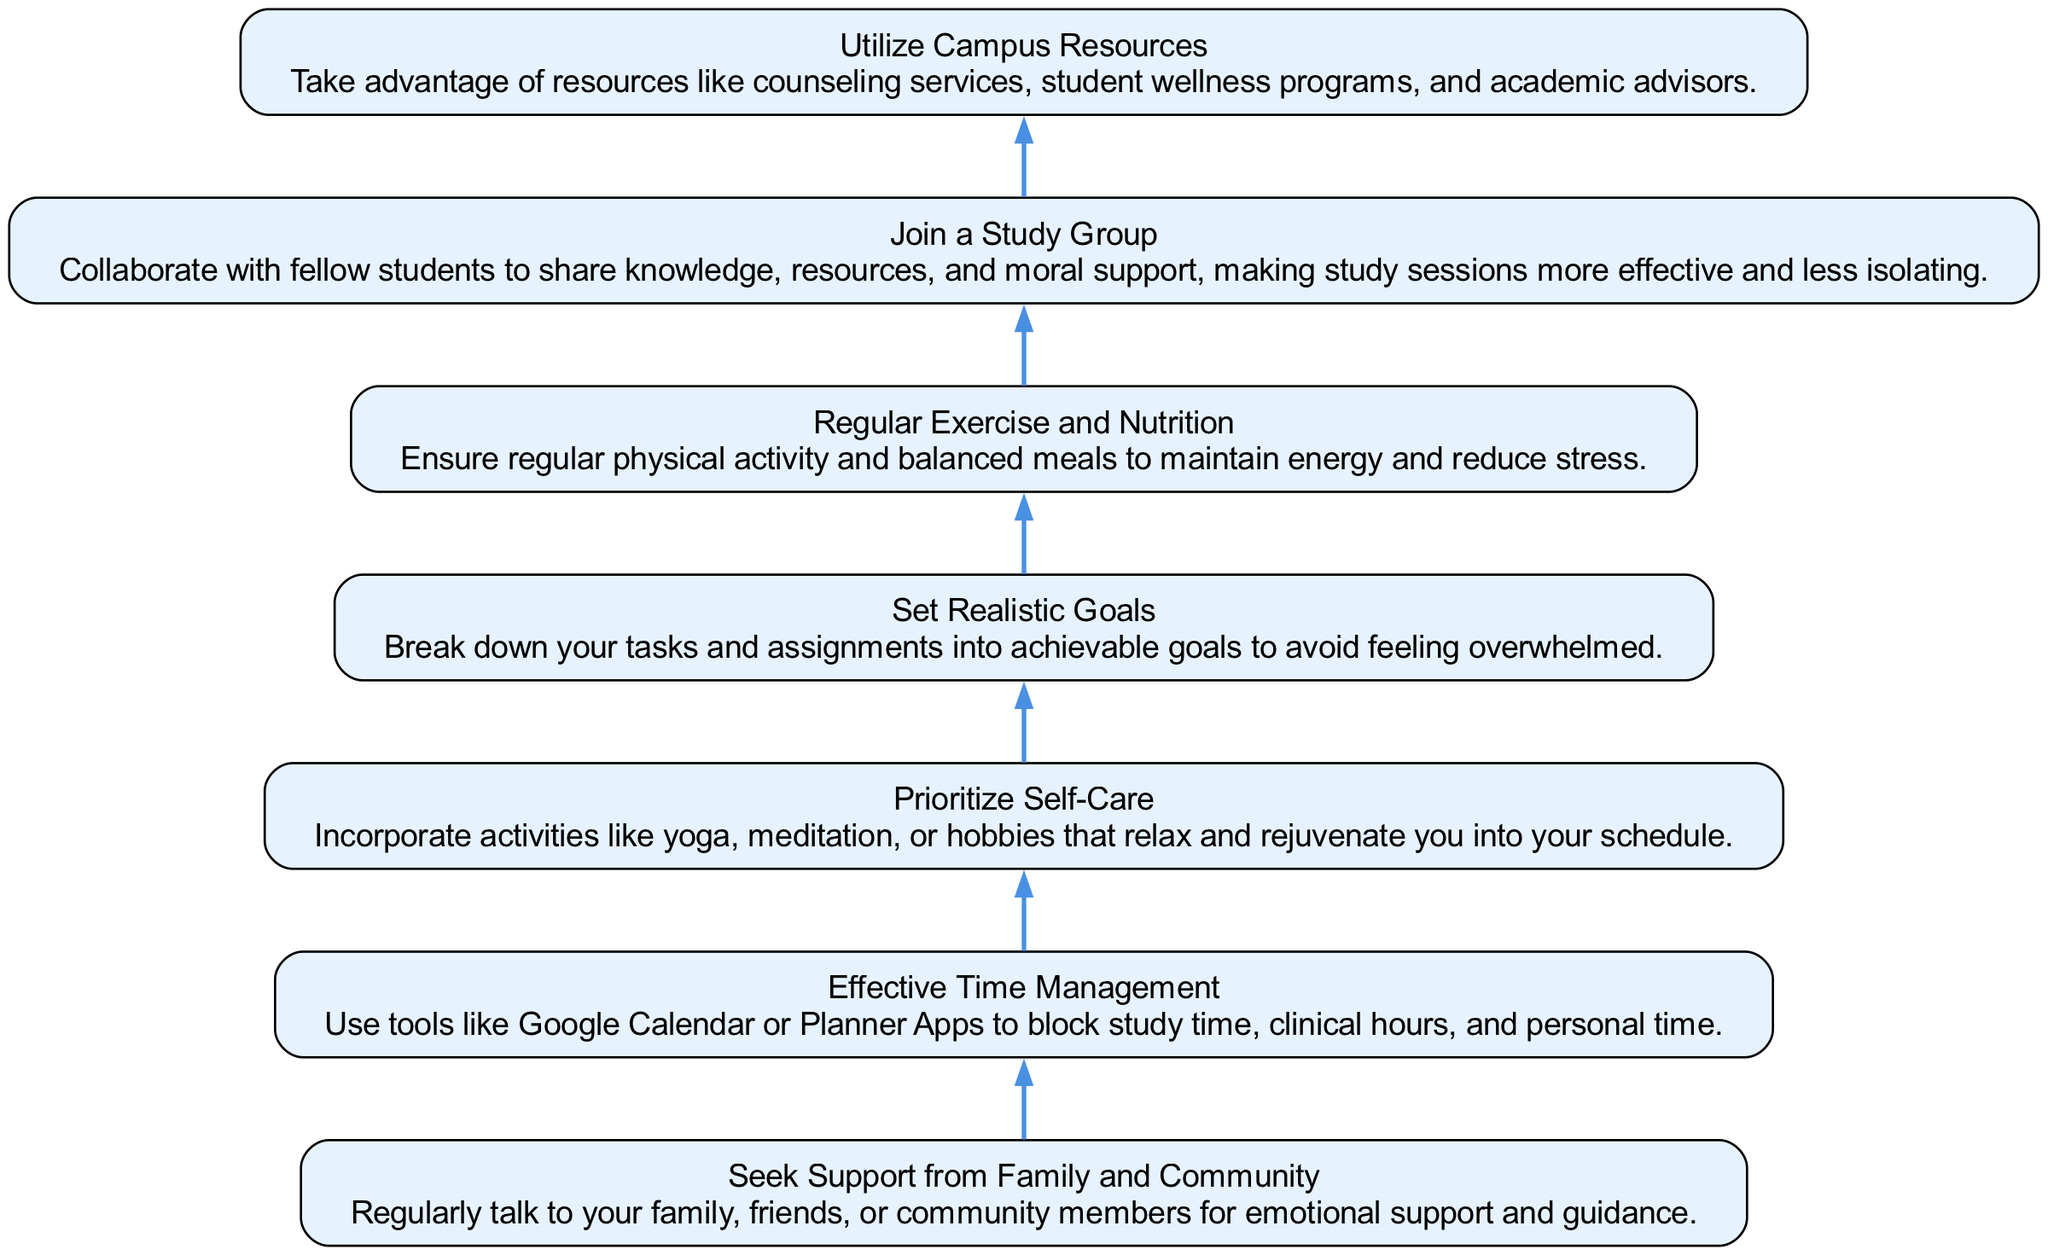What is the first node in the diagram? The first node at the bottom of the diagram states "Seek Support from Family and Community," positioning it as the starting point for handling stress.
Answer: Seek Support from Family and Community How many nodes are in the diagram? By counting each step in the flow from bottom to top, there are a total of seven nodes representing different strategies for managing a stressful schedule.
Answer: 7 What is the last node in the flow chart? The last node at the top of the diagram states "Utilize Campus Resources," which is the final step suggested for handling a stressful nursing student schedule.
Answer: Utilize Campus Resources What connects "Set Realistic Goals" and "Prioritize Self-Care"? "Set Realistic Goals" connects to "Prioritize Self-Care" through the directed flow that emphasizes organizing tasks before focusing on self-care practices.
Answer: Directed flow Which two nodes are located directly below "Regular Exercise and Nutrition"? The nodes directly below "Regular Exercise and Nutrition" are "Set Realistic Goals" and "Prioritize Self-Care," indicating they are the next steps in the flow after addressing nutrition and exercise.
Answer: Set Realistic Goals, Prioritize Self-Care What process should be followed to manage stress according to the chart? To manage stress, one should start by seeking support, then move to set realistic goals, prioritize self-care, exercise, manage time, join study groups, and utilize campus resources, following the flow upward.
Answer: Seek Support, Set Realistic Goals, Prioritize Self-Care, Regular Exercise, Time Management, Join Study Group, Utilize Resources What does the diagram suggest as a method for academic collaboration? The diagram suggests joining a study group as a method for academic collaboration among nursing students, emphasizing teamwork and sharing resources.
Answer: Join a Study Group Which node suggests improving personal well-being through activities? "Prioritize Self-Care" suggests incorporating activities like yoga, meditation, or hobbies that enhance personal well-being into the nursing student’s schedule.
Answer: Prioritize Self-Care 